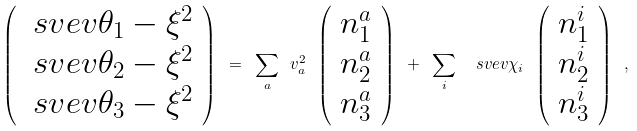Convert formula to latex. <formula><loc_0><loc_0><loc_500><loc_500>\left ( \begin{array} { c } \ s v e v { \theta _ { 1 } } - \xi ^ { 2 } \\ \ s v e v { \theta _ { 2 } } - \xi ^ { 2 } \\ \ s v e v { \theta _ { 3 } } - \xi ^ { 2 } \end{array} \right ) \ = \ \sum _ { a } \ v ^ { 2 } _ { a } \ \left ( \begin{array} { c } n ^ { a } _ { 1 } \\ n ^ { a } _ { 2 } \\ n ^ { a } _ { 3 } \end{array} \right ) \ + \ \sum _ { i } \ \ s v e v { \chi _ { i } } \ \left ( \begin{array} { c } n ^ { i } _ { 1 } \\ n ^ { i } _ { 2 } \\ n ^ { i } _ { 3 } \end{array} \right ) \ ,</formula> 